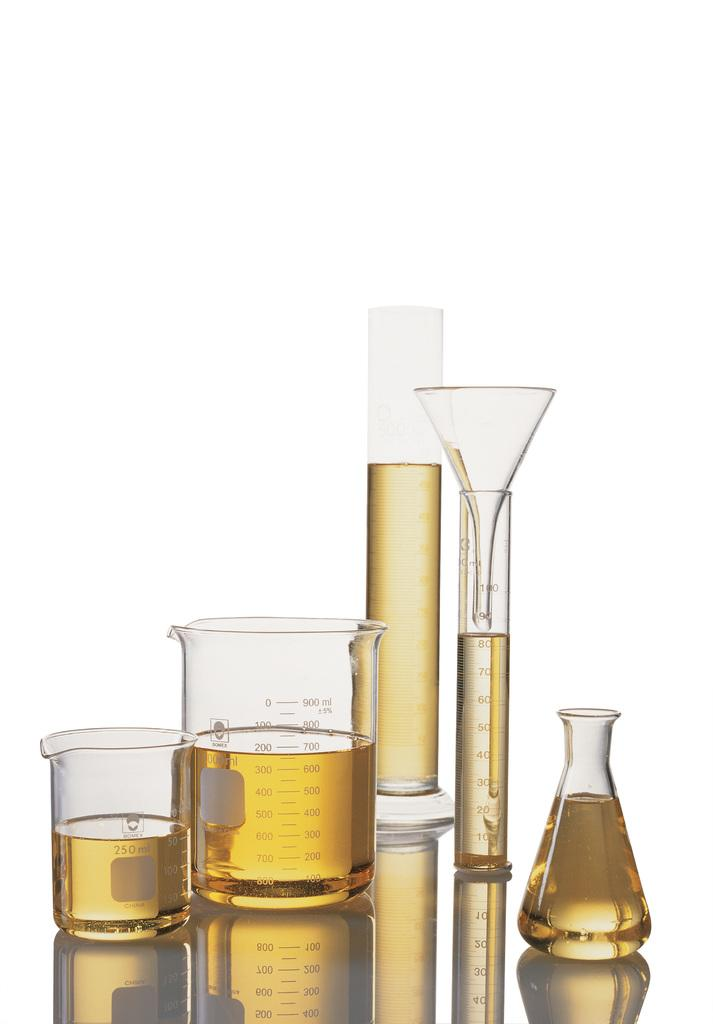<image>
Provide a brief description of the given image. Several beakers with a 250ml measuring cup with a golden liquid in them. 